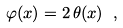<formula> <loc_0><loc_0><loc_500><loc_500>\varphi ( { x } ) = 2 \, \theta ( { x } ) \ ,</formula> 